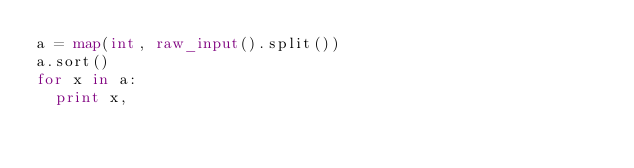Convert code to text. <code><loc_0><loc_0><loc_500><loc_500><_Python_>a = map(int, raw_input().split())
a.sort()
for x in a:
  print x,</code> 